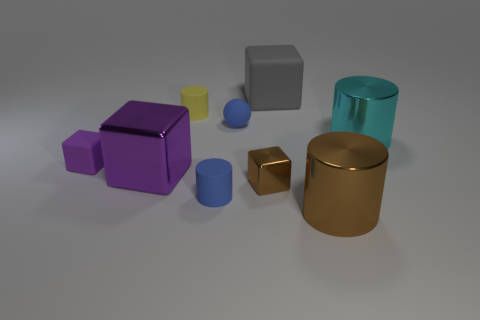Subtract 1 blocks. How many blocks are left? 3 Subtract all purple blocks. Subtract all blue balls. How many blocks are left? 2 Add 1 tiny rubber spheres. How many objects exist? 10 Subtract all cylinders. How many objects are left? 5 Add 6 small blue cylinders. How many small blue cylinders are left? 7 Add 2 yellow rubber objects. How many yellow rubber objects exist? 3 Subtract 1 yellow cylinders. How many objects are left? 8 Subtract all big brown shiny spheres. Subtract all spheres. How many objects are left? 8 